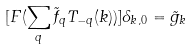<formula> <loc_0><loc_0><loc_500><loc_500>[ F ( \sum _ { q } \tilde { f } _ { q } T _ { - q } ( k ) ) ] \delta _ { k , 0 } = \tilde { g } _ { k }</formula> 